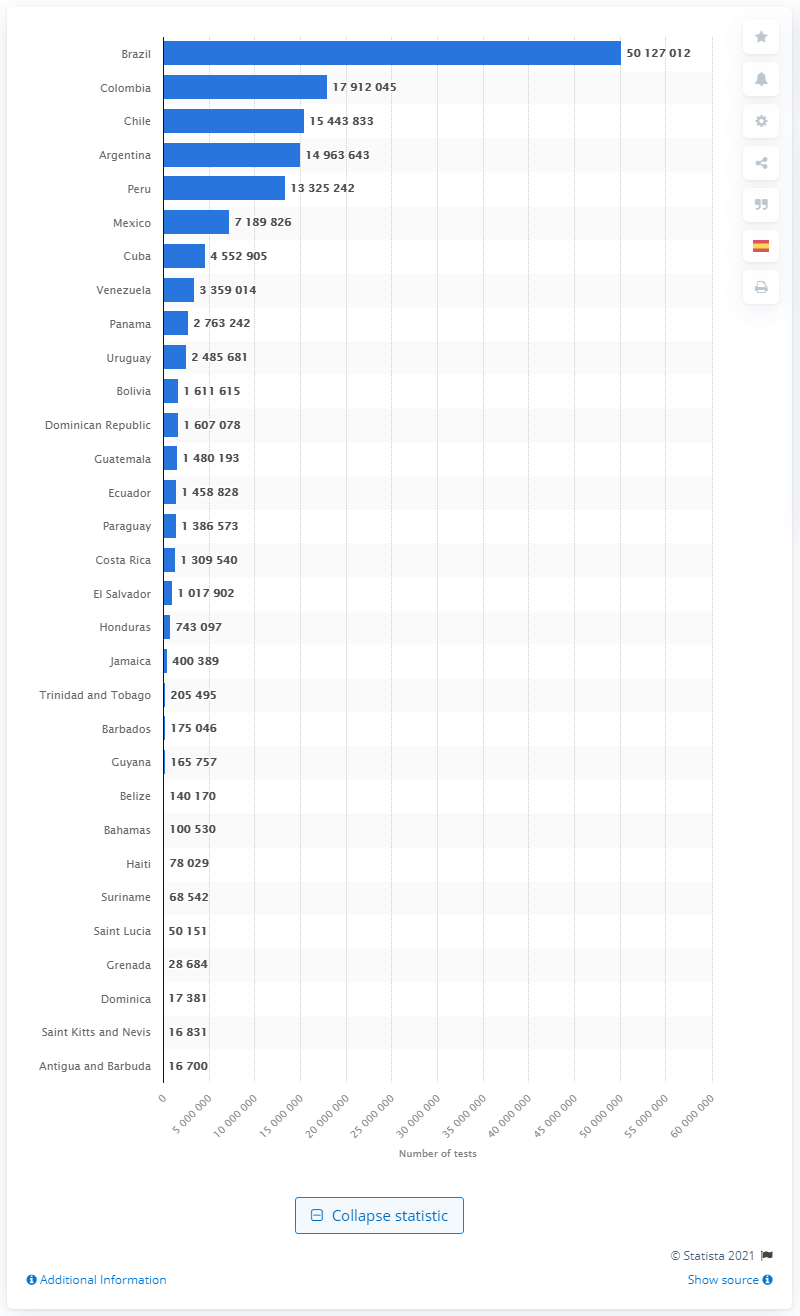Give some essential details in this illustration. Brazil has the largest number of COVID-19 infections among countries. 